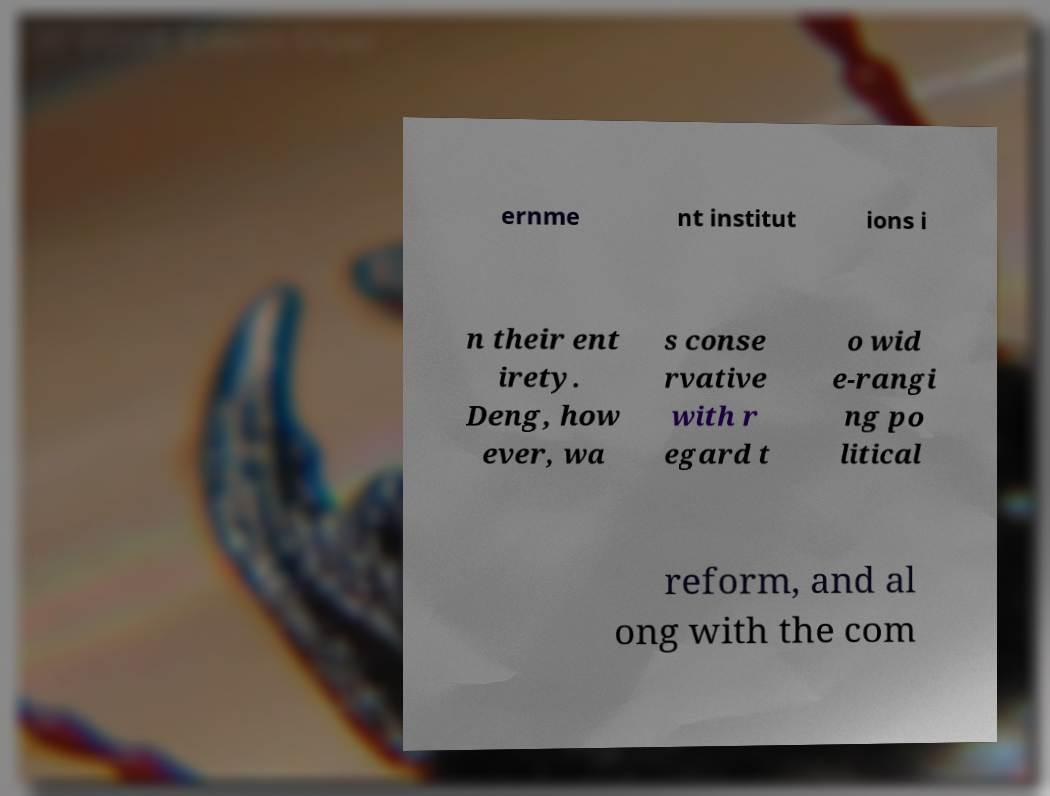What messages or text are displayed in this image? I need them in a readable, typed format. ernme nt institut ions i n their ent irety. Deng, how ever, wa s conse rvative with r egard t o wid e-rangi ng po litical reform, and al ong with the com 